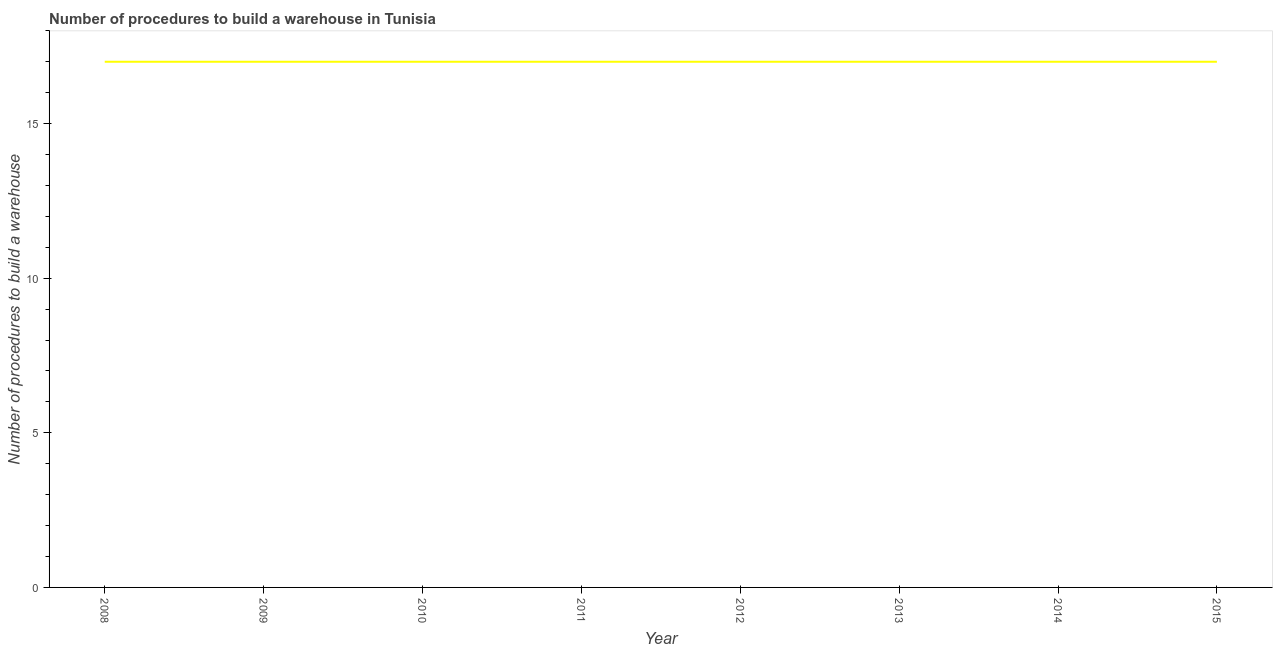What is the number of procedures to build a warehouse in 2008?
Provide a succinct answer. 17. Across all years, what is the maximum number of procedures to build a warehouse?
Give a very brief answer. 17. Across all years, what is the minimum number of procedures to build a warehouse?
Your answer should be very brief. 17. In which year was the number of procedures to build a warehouse maximum?
Make the answer very short. 2008. In which year was the number of procedures to build a warehouse minimum?
Provide a short and direct response. 2008. What is the sum of the number of procedures to build a warehouse?
Your response must be concise. 136. Do a majority of the years between 2014 and 2008 (inclusive) have number of procedures to build a warehouse greater than 1 ?
Provide a succinct answer. Yes. In how many years, is the number of procedures to build a warehouse greater than the average number of procedures to build a warehouse taken over all years?
Make the answer very short. 0. Does the number of procedures to build a warehouse monotonically increase over the years?
Your answer should be compact. No. How many lines are there?
Give a very brief answer. 1. What is the difference between two consecutive major ticks on the Y-axis?
Offer a terse response. 5. Are the values on the major ticks of Y-axis written in scientific E-notation?
Provide a short and direct response. No. Does the graph contain any zero values?
Your answer should be compact. No. Does the graph contain grids?
Provide a short and direct response. No. What is the title of the graph?
Provide a succinct answer. Number of procedures to build a warehouse in Tunisia. What is the label or title of the X-axis?
Give a very brief answer. Year. What is the label or title of the Y-axis?
Make the answer very short. Number of procedures to build a warehouse. What is the Number of procedures to build a warehouse of 2010?
Provide a short and direct response. 17. What is the Number of procedures to build a warehouse of 2012?
Provide a short and direct response. 17. What is the Number of procedures to build a warehouse of 2015?
Your answer should be very brief. 17. What is the difference between the Number of procedures to build a warehouse in 2008 and 2010?
Offer a terse response. 0. What is the difference between the Number of procedures to build a warehouse in 2008 and 2011?
Offer a terse response. 0. What is the difference between the Number of procedures to build a warehouse in 2008 and 2012?
Keep it short and to the point. 0. What is the difference between the Number of procedures to build a warehouse in 2009 and 2011?
Give a very brief answer. 0. What is the difference between the Number of procedures to build a warehouse in 2009 and 2012?
Provide a succinct answer. 0. What is the difference between the Number of procedures to build a warehouse in 2009 and 2013?
Offer a very short reply. 0. What is the difference between the Number of procedures to build a warehouse in 2010 and 2012?
Keep it short and to the point. 0. What is the difference between the Number of procedures to build a warehouse in 2010 and 2013?
Your response must be concise. 0. What is the difference between the Number of procedures to build a warehouse in 2010 and 2014?
Provide a short and direct response. 0. What is the difference between the Number of procedures to build a warehouse in 2011 and 2014?
Make the answer very short. 0. What is the difference between the Number of procedures to build a warehouse in 2012 and 2014?
Make the answer very short. 0. What is the difference between the Number of procedures to build a warehouse in 2012 and 2015?
Give a very brief answer. 0. What is the difference between the Number of procedures to build a warehouse in 2013 and 2014?
Your response must be concise. 0. What is the difference between the Number of procedures to build a warehouse in 2013 and 2015?
Give a very brief answer. 0. What is the difference between the Number of procedures to build a warehouse in 2014 and 2015?
Give a very brief answer. 0. What is the ratio of the Number of procedures to build a warehouse in 2008 to that in 2010?
Keep it short and to the point. 1. What is the ratio of the Number of procedures to build a warehouse in 2008 to that in 2011?
Give a very brief answer. 1. What is the ratio of the Number of procedures to build a warehouse in 2008 to that in 2012?
Ensure brevity in your answer.  1. What is the ratio of the Number of procedures to build a warehouse in 2008 to that in 2013?
Give a very brief answer. 1. What is the ratio of the Number of procedures to build a warehouse in 2008 to that in 2014?
Your response must be concise. 1. What is the ratio of the Number of procedures to build a warehouse in 2009 to that in 2012?
Give a very brief answer. 1. What is the ratio of the Number of procedures to build a warehouse in 2009 to that in 2014?
Make the answer very short. 1. What is the ratio of the Number of procedures to build a warehouse in 2010 to that in 2013?
Ensure brevity in your answer.  1. What is the ratio of the Number of procedures to build a warehouse in 2010 to that in 2014?
Make the answer very short. 1. What is the ratio of the Number of procedures to build a warehouse in 2011 to that in 2012?
Provide a succinct answer. 1. What is the ratio of the Number of procedures to build a warehouse in 2011 to that in 2013?
Your answer should be very brief. 1. What is the ratio of the Number of procedures to build a warehouse in 2011 to that in 2015?
Offer a very short reply. 1. What is the ratio of the Number of procedures to build a warehouse in 2012 to that in 2015?
Ensure brevity in your answer.  1. What is the ratio of the Number of procedures to build a warehouse in 2013 to that in 2015?
Your answer should be very brief. 1. 